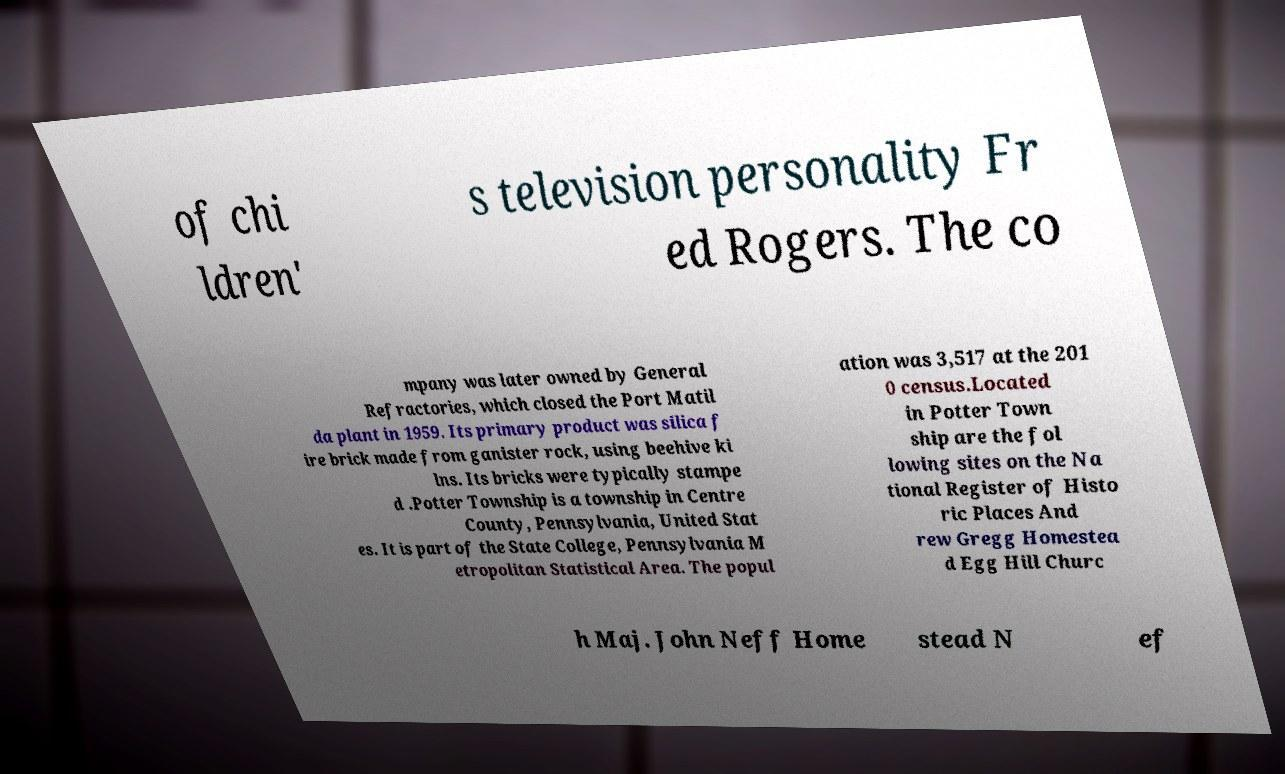Could you assist in decoding the text presented in this image and type it out clearly? of chi ldren' s television personality Fr ed Rogers. The co mpany was later owned by General Refractories, which closed the Port Matil da plant in 1959. Its primary product was silica f ire brick made from ganister rock, using beehive ki lns. Its bricks were typically stampe d .Potter Township is a township in Centre County, Pennsylvania, United Stat es. It is part of the State College, Pennsylvania M etropolitan Statistical Area. The popul ation was 3,517 at the 201 0 census.Located in Potter Town ship are the fol lowing sites on the Na tional Register of Histo ric Places And rew Gregg Homestea d Egg Hill Churc h Maj. John Neff Home stead N ef 